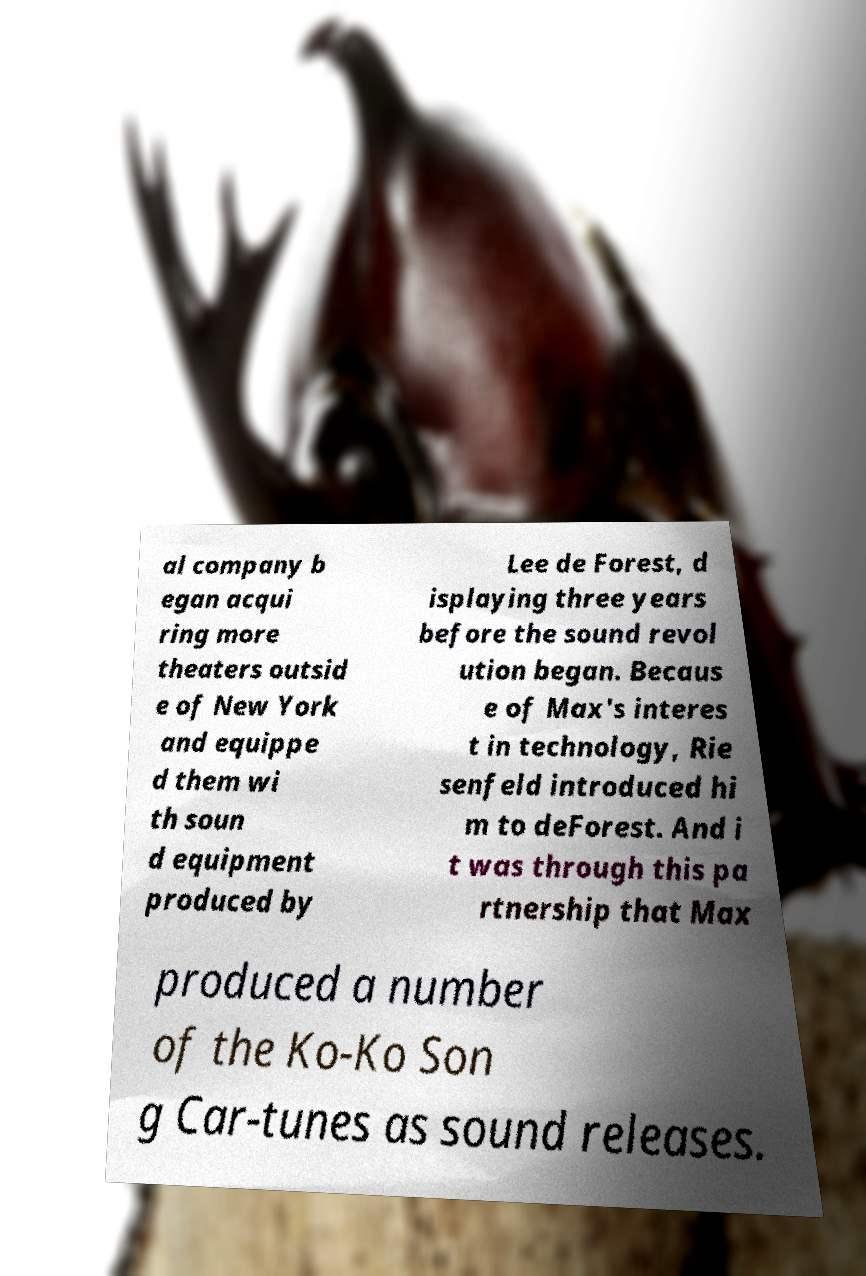Could you extract and type out the text from this image? al company b egan acqui ring more theaters outsid e of New York and equippe d them wi th soun d equipment produced by Lee de Forest, d isplaying three years before the sound revol ution began. Becaus e of Max's interes t in technology, Rie senfeld introduced hi m to deForest. And i t was through this pa rtnership that Max produced a number of the Ko-Ko Son g Car-tunes as sound releases. 